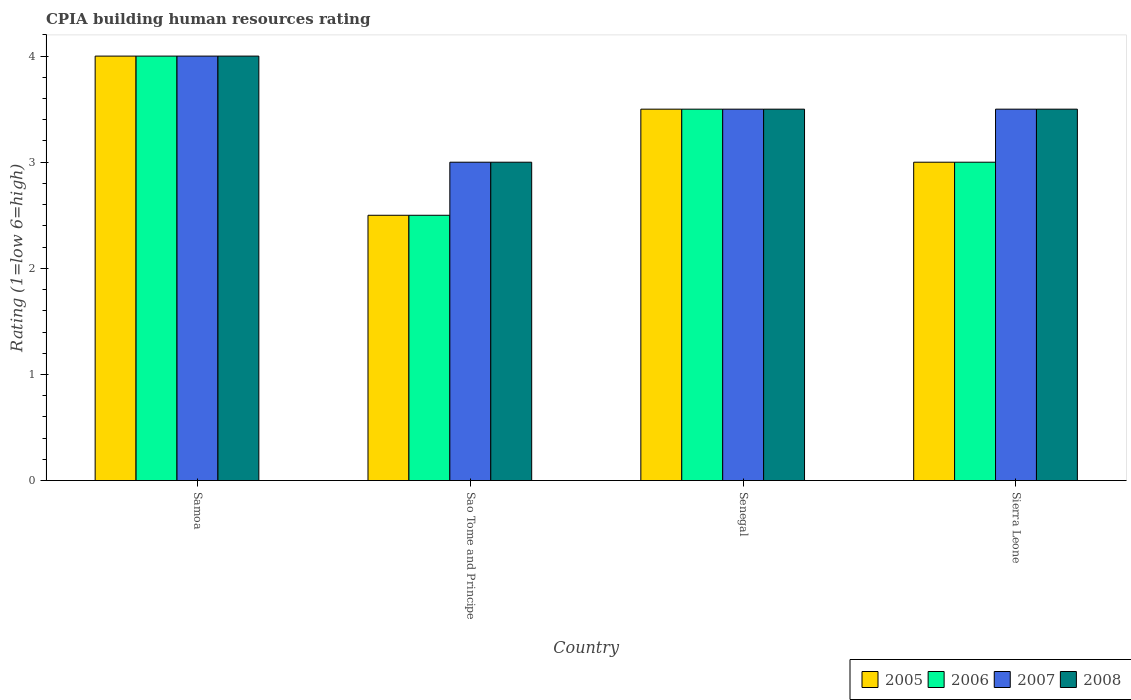How many groups of bars are there?
Make the answer very short. 4. Are the number of bars per tick equal to the number of legend labels?
Your answer should be compact. Yes. What is the label of the 4th group of bars from the left?
Provide a short and direct response. Sierra Leone. In how many cases, is the number of bars for a given country not equal to the number of legend labels?
Give a very brief answer. 0. What is the CPIA rating in 2007 in Senegal?
Provide a succinct answer. 3.5. Across all countries, what is the maximum CPIA rating in 2005?
Give a very brief answer. 4. Across all countries, what is the minimum CPIA rating in 2005?
Keep it short and to the point. 2.5. In which country was the CPIA rating in 2006 maximum?
Your answer should be very brief. Samoa. In which country was the CPIA rating in 2008 minimum?
Ensure brevity in your answer.  Sao Tome and Principe. What is the average CPIA rating in 2008 per country?
Provide a short and direct response. 3.5. What is the difference between the CPIA rating of/in 2006 and CPIA rating of/in 2007 in Sierra Leone?
Your response must be concise. -0.5. What is the ratio of the CPIA rating in 2008 in Sao Tome and Principe to that in Sierra Leone?
Your answer should be compact. 0.86. Is the difference between the CPIA rating in 2006 in Samoa and Sierra Leone greater than the difference between the CPIA rating in 2007 in Samoa and Sierra Leone?
Your answer should be very brief. Yes. Is it the case that in every country, the sum of the CPIA rating in 2008 and CPIA rating in 2007 is greater than the sum of CPIA rating in 2005 and CPIA rating in 2006?
Offer a very short reply. No. What does the 1st bar from the left in Samoa represents?
Provide a succinct answer. 2005. Is it the case that in every country, the sum of the CPIA rating in 2008 and CPIA rating in 2006 is greater than the CPIA rating in 2007?
Provide a succinct answer. Yes. How many bars are there?
Make the answer very short. 16. How many countries are there in the graph?
Your response must be concise. 4. What is the difference between two consecutive major ticks on the Y-axis?
Give a very brief answer. 1. Are the values on the major ticks of Y-axis written in scientific E-notation?
Your answer should be very brief. No. How are the legend labels stacked?
Make the answer very short. Horizontal. What is the title of the graph?
Offer a very short reply. CPIA building human resources rating. What is the label or title of the X-axis?
Your response must be concise. Country. What is the Rating (1=low 6=high) of 2006 in Samoa?
Your answer should be compact. 4. What is the Rating (1=low 6=high) of 2007 in Samoa?
Your response must be concise. 4. What is the Rating (1=low 6=high) in 2008 in Sao Tome and Principe?
Provide a succinct answer. 3. What is the Rating (1=low 6=high) of 2007 in Senegal?
Your response must be concise. 3.5. What is the Rating (1=low 6=high) of 2008 in Senegal?
Provide a short and direct response. 3.5. What is the Rating (1=low 6=high) in 2005 in Sierra Leone?
Ensure brevity in your answer.  3. What is the Rating (1=low 6=high) in 2006 in Sierra Leone?
Ensure brevity in your answer.  3. What is the Rating (1=low 6=high) of 2008 in Sierra Leone?
Your response must be concise. 3.5. Across all countries, what is the maximum Rating (1=low 6=high) in 2006?
Give a very brief answer. 4. Across all countries, what is the maximum Rating (1=low 6=high) of 2007?
Provide a succinct answer. 4. Across all countries, what is the maximum Rating (1=low 6=high) in 2008?
Provide a short and direct response. 4. Across all countries, what is the minimum Rating (1=low 6=high) of 2006?
Your response must be concise. 2.5. Across all countries, what is the minimum Rating (1=low 6=high) in 2007?
Give a very brief answer. 3. Across all countries, what is the minimum Rating (1=low 6=high) in 2008?
Make the answer very short. 3. What is the total Rating (1=low 6=high) of 2006 in the graph?
Provide a succinct answer. 13. What is the total Rating (1=low 6=high) in 2007 in the graph?
Make the answer very short. 14. What is the difference between the Rating (1=low 6=high) in 2005 in Samoa and that in Sao Tome and Principe?
Ensure brevity in your answer.  1.5. What is the difference between the Rating (1=low 6=high) of 2006 in Samoa and that in Sao Tome and Principe?
Your answer should be compact. 1.5. What is the difference between the Rating (1=low 6=high) in 2007 in Samoa and that in Sao Tome and Principe?
Provide a succinct answer. 1. What is the difference between the Rating (1=low 6=high) in 2005 in Samoa and that in Senegal?
Your response must be concise. 0.5. What is the difference between the Rating (1=low 6=high) of 2006 in Samoa and that in Senegal?
Your response must be concise. 0.5. What is the difference between the Rating (1=low 6=high) in 2007 in Samoa and that in Senegal?
Provide a short and direct response. 0.5. What is the difference between the Rating (1=low 6=high) of 2008 in Samoa and that in Senegal?
Offer a very short reply. 0.5. What is the difference between the Rating (1=low 6=high) of 2006 in Samoa and that in Sierra Leone?
Offer a very short reply. 1. What is the difference between the Rating (1=low 6=high) of 2007 in Samoa and that in Sierra Leone?
Your response must be concise. 0.5. What is the difference between the Rating (1=low 6=high) in 2008 in Samoa and that in Sierra Leone?
Give a very brief answer. 0.5. What is the difference between the Rating (1=low 6=high) of 2006 in Sao Tome and Principe and that in Sierra Leone?
Ensure brevity in your answer.  -0.5. What is the difference between the Rating (1=low 6=high) of 2007 in Sao Tome and Principe and that in Sierra Leone?
Offer a terse response. -0.5. What is the difference between the Rating (1=low 6=high) of 2008 in Senegal and that in Sierra Leone?
Make the answer very short. 0. What is the difference between the Rating (1=low 6=high) of 2005 in Samoa and the Rating (1=low 6=high) of 2008 in Sao Tome and Principe?
Give a very brief answer. 1. What is the difference between the Rating (1=low 6=high) in 2006 in Samoa and the Rating (1=low 6=high) in 2007 in Sao Tome and Principe?
Make the answer very short. 1. What is the difference between the Rating (1=low 6=high) of 2006 in Samoa and the Rating (1=low 6=high) of 2008 in Sao Tome and Principe?
Your response must be concise. 1. What is the difference between the Rating (1=low 6=high) in 2005 in Samoa and the Rating (1=low 6=high) in 2006 in Senegal?
Your response must be concise. 0.5. What is the difference between the Rating (1=low 6=high) in 2005 in Samoa and the Rating (1=low 6=high) in 2008 in Senegal?
Keep it short and to the point. 0.5. What is the difference between the Rating (1=low 6=high) in 2006 in Samoa and the Rating (1=low 6=high) in 2008 in Senegal?
Your answer should be compact. 0.5. What is the difference between the Rating (1=low 6=high) in 2007 in Samoa and the Rating (1=low 6=high) in 2008 in Senegal?
Offer a very short reply. 0.5. What is the difference between the Rating (1=low 6=high) of 2005 in Samoa and the Rating (1=low 6=high) of 2006 in Sierra Leone?
Your answer should be compact. 1. What is the difference between the Rating (1=low 6=high) of 2005 in Samoa and the Rating (1=low 6=high) of 2007 in Sierra Leone?
Your response must be concise. 0.5. What is the difference between the Rating (1=low 6=high) of 2005 in Samoa and the Rating (1=low 6=high) of 2008 in Sierra Leone?
Make the answer very short. 0.5. What is the difference between the Rating (1=low 6=high) of 2007 in Samoa and the Rating (1=low 6=high) of 2008 in Sierra Leone?
Provide a short and direct response. 0.5. What is the difference between the Rating (1=low 6=high) of 2005 in Sao Tome and Principe and the Rating (1=low 6=high) of 2006 in Senegal?
Provide a succinct answer. -1. What is the difference between the Rating (1=low 6=high) of 2006 in Sao Tome and Principe and the Rating (1=low 6=high) of 2008 in Senegal?
Ensure brevity in your answer.  -1. What is the difference between the Rating (1=low 6=high) of 2005 in Sao Tome and Principe and the Rating (1=low 6=high) of 2006 in Sierra Leone?
Provide a succinct answer. -0.5. What is the difference between the Rating (1=low 6=high) in 2005 in Sao Tome and Principe and the Rating (1=low 6=high) in 2008 in Sierra Leone?
Your answer should be compact. -1. What is the difference between the Rating (1=low 6=high) of 2006 in Sao Tome and Principe and the Rating (1=low 6=high) of 2007 in Sierra Leone?
Give a very brief answer. -1. What is the difference between the Rating (1=low 6=high) in 2006 in Sao Tome and Principe and the Rating (1=low 6=high) in 2008 in Sierra Leone?
Ensure brevity in your answer.  -1. What is the difference between the Rating (1=low 6=high) of 2005 in Senegal and the Rating (1=low 6=high) of 2008 in Sierra Leone?
Give a very brief answer. 0. What is the difference between the Rating (1=low 6=high) of 2007 in Senegal and the Rating (1=low 6=high) of 2008 in Sierra Leone?
Make the answer very short. 0. What is the average Rating (1=low 6=high) in 2005 per country?
Offer a terse response. 3.25. What is the average Rating (1=low 6=high) in 2007 per country?
Your response must be concise. 3.5. What is the average Rating (1=low 6=high) of 2008 per country?
Offer a terse response. 3.5. What is the difference between the Rating (1=low 6=high) in 2005 and Rating (1=low 6=high) in 2006 in Samoa?
Give a very brief answer. 0. What is the difference between the Rating (1=low 6=high) in 2005 and Rating (1=low 6=high) in 2008 in Samoa?
Give a very brief answer. 0. What is the difference between the Rating (1=low 6=high) of 2006 and Rating (1=low 6=high) of 2007 in Samoa?
Keep it short and to the point. 0. What is the difference between the Rating (1=low 6=high) of 2005 and Rating (1=low 6=high) of 2007 in Sao Tome and Principe?
Make the answer very short. -0.5. What is the difference between the Rating (1=low 6=high) of 2006 and Rating (1=low 6=high) of 2008 in Sao Tome and Principe?
Your response must be concise. -0.5. What is the difference between the Rating (1=low 6=high) of 2005 and Rating (1=low 6=high) of 2007 in Senegal?
Ensure brevity in your answer.  0. What is the difference between the Rating (1=low 6=high) of 2007 and Rating (1=low 6=high) of 2008 in Senegal?
Provide a short and direct response. 0. What is the difference between the Rating (1=low 6=high) of 2006 and Rating (1=low 6=high) of 2007 in Sierra Leone?
Offer a very short reply. -0.5. What is the difference between the Rating (1=low 6=high) of 2007 and Rating (1=low 6=high) of 2008 in Sierra Leone?
Your response must be concise. 0. What is the ratio of the Rating (1=low 6=high) in 2005 in Samoa to that in Sao Tome and Principe?
Your answer should be very brief. 1.6. What is the ratio of the Rating (1=low 6=high) of 2008 in Samoa to that in Sao Tome and Principe?
Your answer should be very brief. 1.33. What is the ratio of the Rating (1=low 6=high) of 2007 in Samoa to that in Senegal?
Provide a succinct answer. 1.14. What is the ratio of the Rating (1=low 6=high) in 2005 in Samoa to that in Sierra Leone?
Offer a terse response. 1.33. What is the ratio of the Rating (1=low 6=high) in 2006 in Samoa to that in Sierra Leone?
Ensure brevity in your answer.  1.33. What is the ratio of the Rating (1=low 6=high) of 2007 in Samoa to that in Sierra Leone?
Your response must be concise. 1.14. What is the ratio of the Rating (1=low 6=high) of 2008 in Samoa to that in Sierra Leone?
Offer a terse response. 1.14. What is the ratio of the Rating (1=low 6=high) in 2005 in Sao Tome and Principe to that in Senegal?
Give a very brief answer. 0.71. What is the ratio of the Rating (1=low 6=high) in 2007 in Sao Tome and Principe to that in Senegal?
Provide a short and direct response. 0.86. What is the ratio of the Rating (1=low 6=high) of 2005 in Sao Tome and Principe to that in Sierra Leone?
Your response must be concise. 0.83. What is the ratio of the Rating (1=low 6=high) of 2006 in Senegal to that in Sierra Leone?
Offer a very short reply. 1.17. What is the difference between the highest and the second highest Rating (1=low 6=high) in 2005?
Provide a succinct answer. 0.5. What is the difference between the highest and the second highest Rating (1=low 6=high) in 2006?
Your response must be concise. 0.5. What is the difference between the highest and the second highest Rating (1=low 6=high) in 2007?
Ensure brevity in your answer.  0.5. What is the difference between the highest and the second highest Rating (1=low 6=high) of 2008?
Provide a short and direct response. 0.5. What is the difference between the highest and the lowest Rating (1=low 6=high) of 2006?
Ensure brevity in your answer.  1.5. 